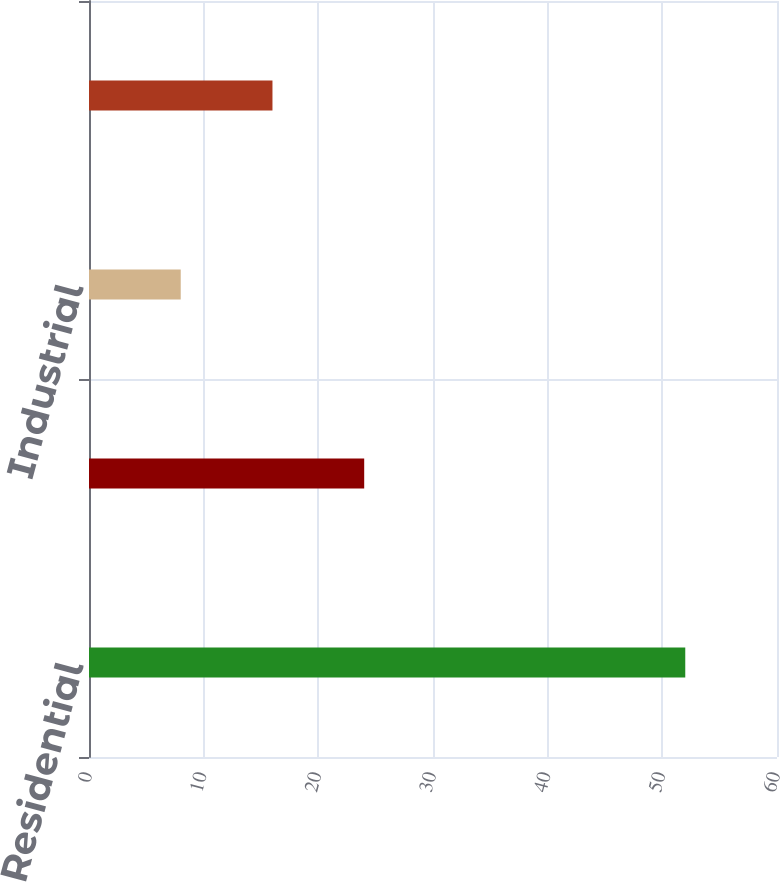Convert chart to OTSL. <chart><loc_0><loc_0><loc_500><loc_500><bar_chart><fcel>Residential<fcel>Commercial<fcel>Industrial<fcel>Governmental/Municipal<nl><fcel>52<fcel>24<fcel>8<fcel>16<nl></chart> 